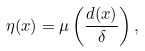<formula> <loc_0><loc_0><loc_500><loc_500>\eta ( x ) = \mu \left ( \frac { d ( x ) } { \delta } \right ) ,</formula> 